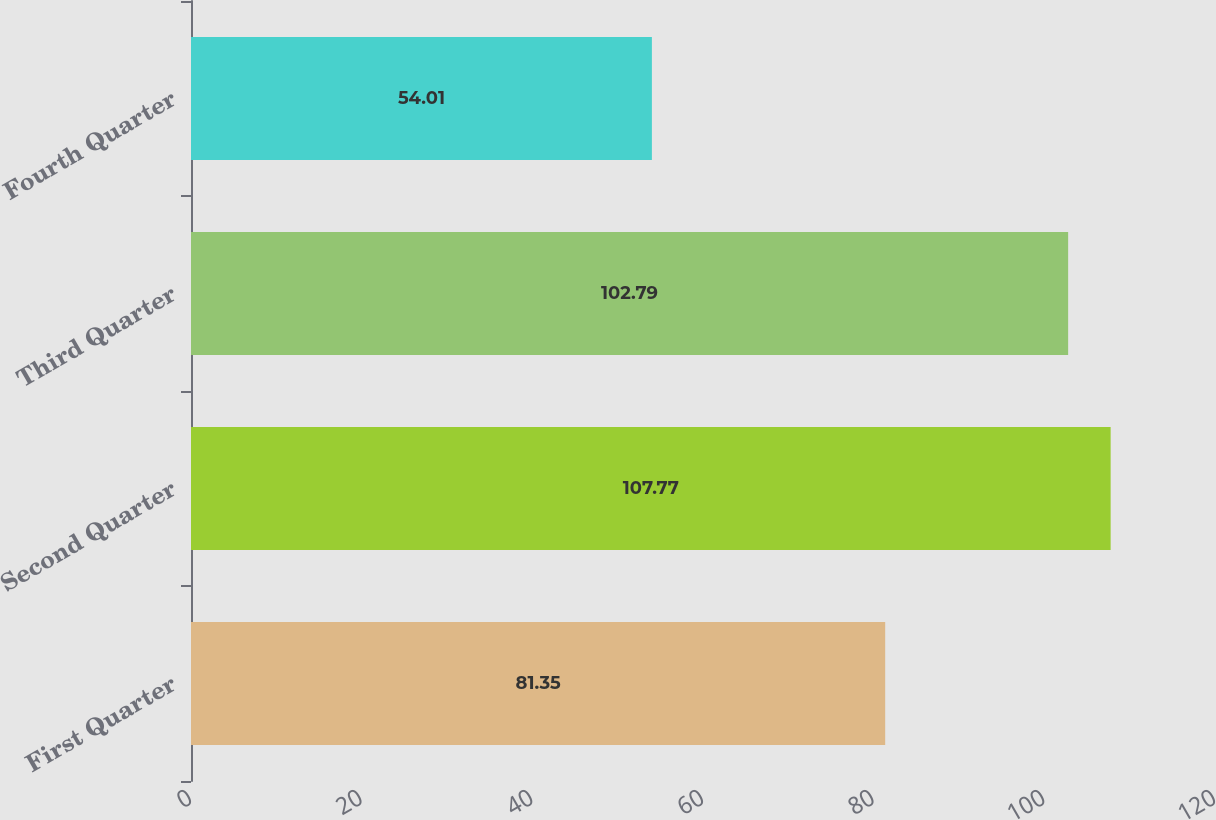Convert chart. <chart><loc_0><loc_0><loc_500><loc_500><bar_chart><fcel>First Quarter<fcel>Second Quarter<fcel>Third Quarter<fcel>Fourth Quarter<nl><fcel>81.35<fcel>107.77<fcel>102.79<fcel>54.01<nl></chart> 